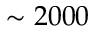Convert formula to latex. <formula><loc_0><loc_0><loc_500><loc_500>\sim 2 0 0 0</formula> 